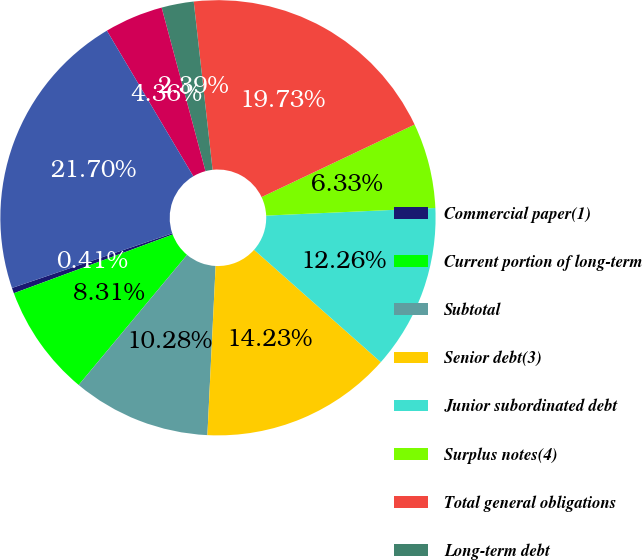<chart> <loc_0><loc_0><loc_500><loc_500><pie_chart><fcel>Commercial paper(1)<fcel>Current portion of long-term<fcel>Subtotal<fcel>Senior debt(3)<fcel>Junior subordinated debt<fcel>Surplus notes(4)<fcel>Total general obligations<fcel>Long-term debt<fcel>Total limited recourse<fcel>Total borrowings<nl><fcel>0.41%<fcel>8.31%<fcel>10.28%<fcel>14.23%<fcel>12.26%<fcel>6.33%<fcel>19.73%<fcel>2.39%<fcel>4.36%<fcel>21.7%<nl></chart> 